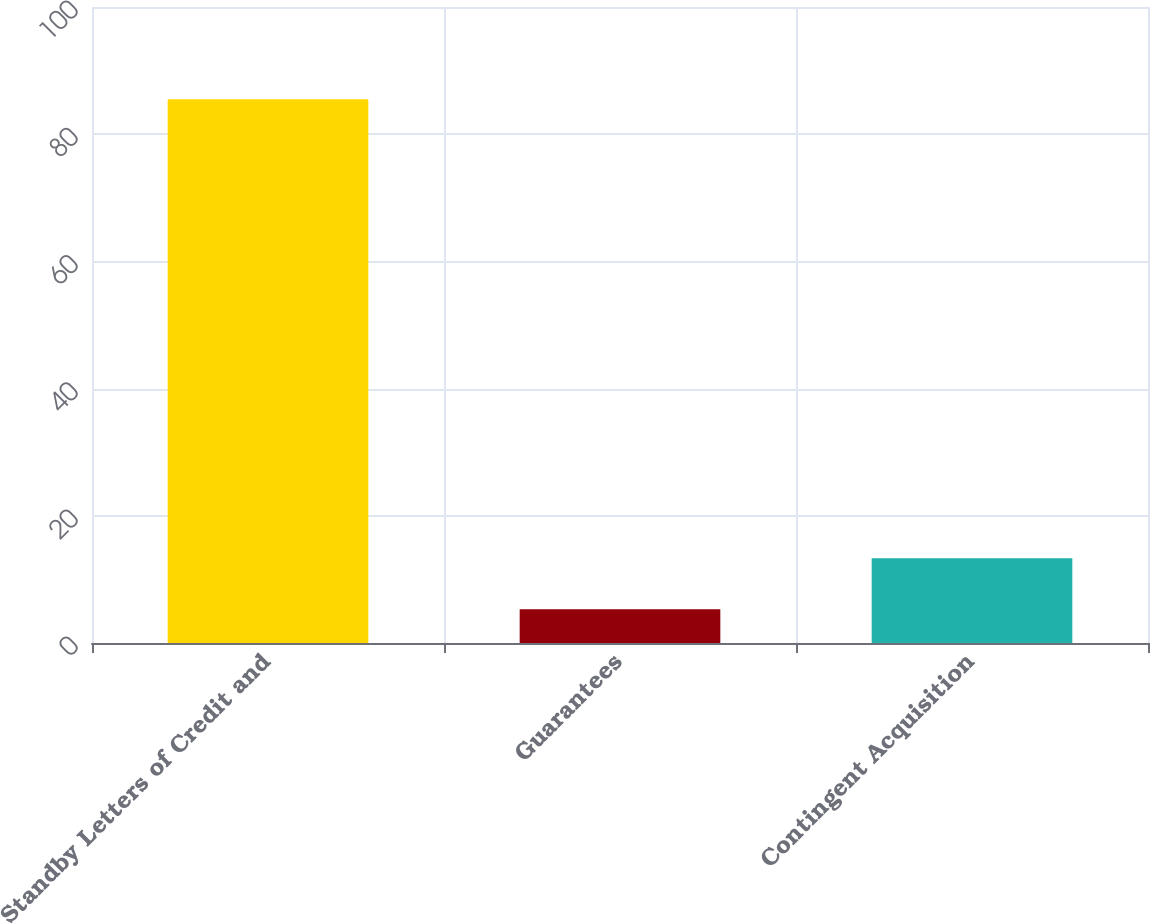<chart> <loc_0><loc_0><loc_500><loc_500><bar_chart><fcel>Standby Letters of Credit and<fcel>Guarantees<fcel>Contingent Acquisition<nl><fcel>85.5<fcel>5.3<fcel>13.32<nl></chart> 